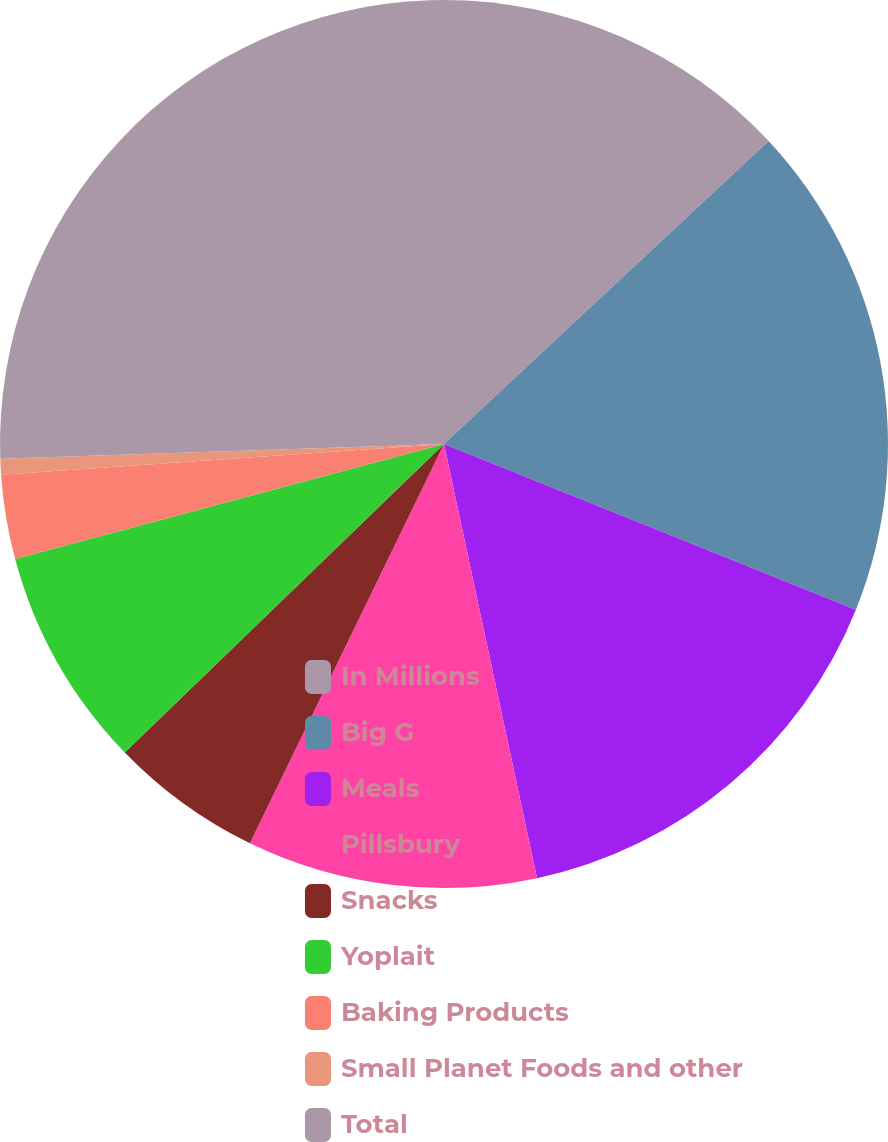<chart> <loc_0><loc_0><loc_500><loc_500><pie_chart><fcel>In Millions<fcel>Big G<fcel>Meals<fcel>Pillsbury<fcel>Snacks<fcel>Yoplait<fcel>Baking Products<fcel>Small Planet Foods and other<fcel>Total<nl><fcel>13.05%<fcel>18.04%<fcel>15.55%<fcel>10.56%<fcel>5.57%<fcel>8.06%<fcel>3.07%<fcel>0.57%<fcel>25.53%<nl></chart> 